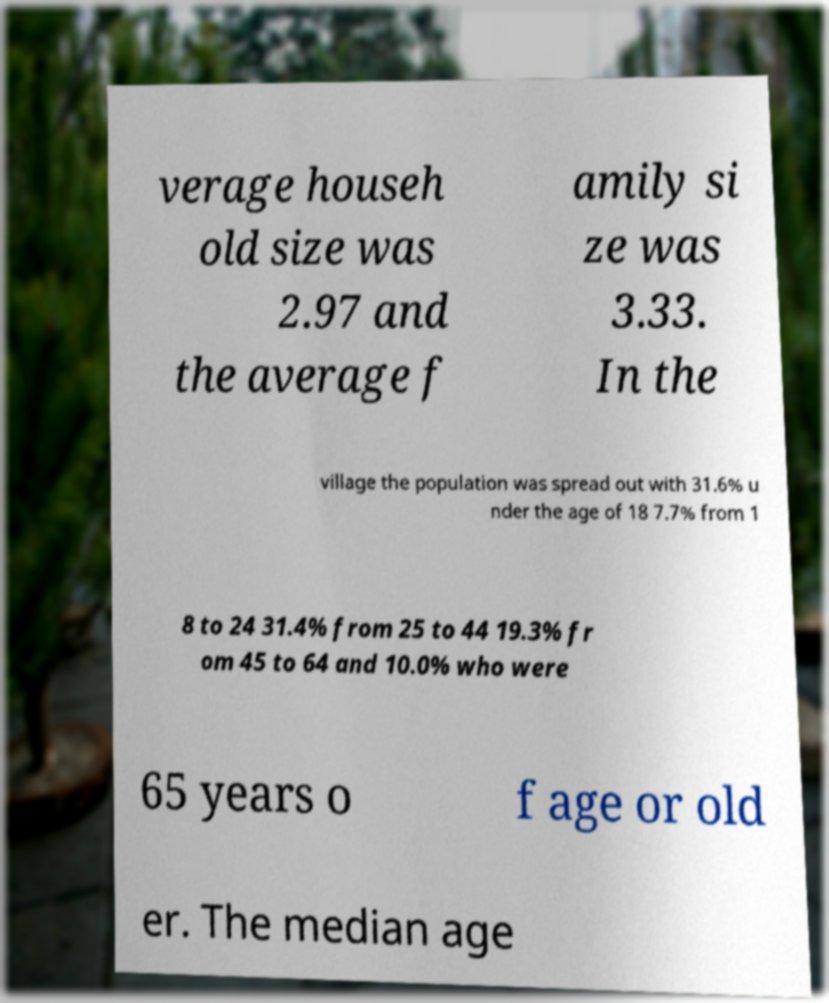Could you assist in decoding the text presented in this image and type it out clearly? verage househ old size was 2.97 and the average f amily si ze was 3.33. In the village the population was spread out with 31.6% u nder the age of 18 7.7% from 1 8 to 24 31.4% from 25 to 44 19.3% fr om 45 to 64 and 10.0% who were 65 years o f age or old er. The median age 